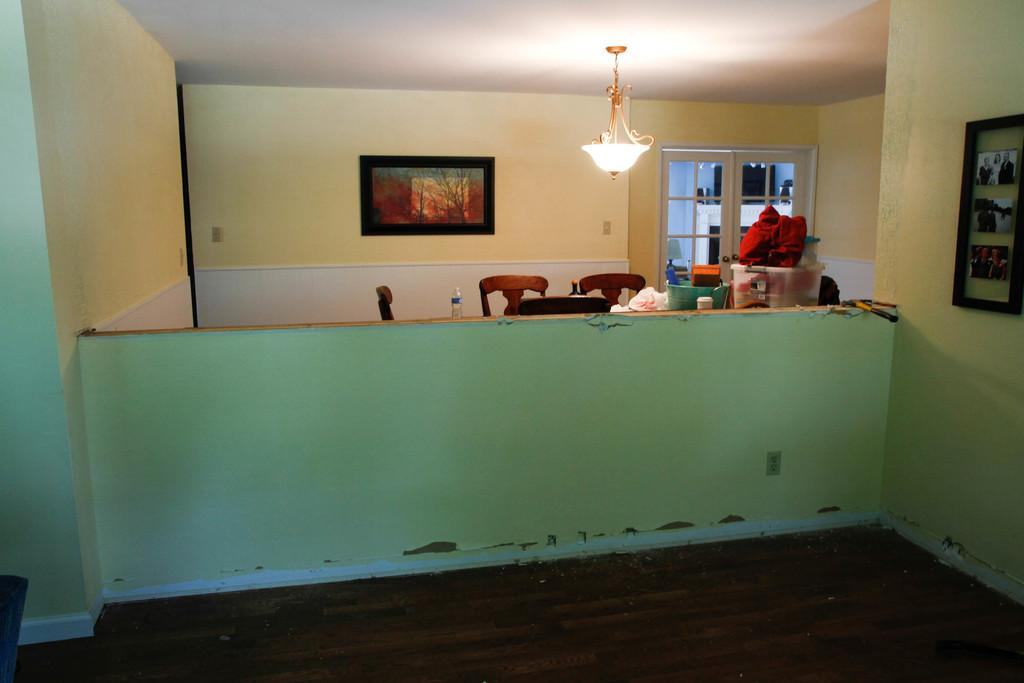What type of space is depicted in the image? The image shows a room. What lighting source is present in the room? There is a lamp in the room. What decoration can be seen on the wall? There is a scenery on the wall. What type of furniture is in the room? There are chairs in the room. What additional object can be found in the room? There is a basket in the room. How does the mother interact with the pump in the image? There is no pump or mother present in the image. 